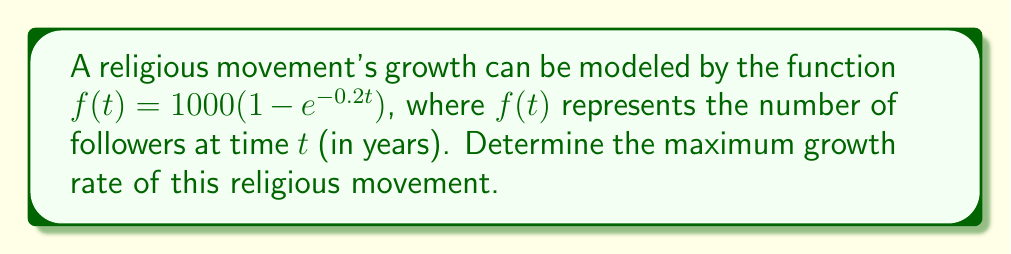Provide a solution to this math problem. To find the maximum growth rate, we need to follow these steps:

1) First, we need to find the derivative of $f(t)$ with respect to $t$. This will give us the growth rate function.

   $f'(t) = 1000 \cdot 0.2e^{-0.2t} = 200e^{-0.2t}$

2) The growth rate function $f'(t)$ represents the rate of change of followers over time. To find the maximum growth rate, we need to find the maximum value of this function.

3) In this case, $f'(t)$ is a decreasing exponential function. Its maximum value occurs at $t = 0$.

4) Therefore, we can find the maximum growth rate by evaluating $f'(0)$:

   $f'(0) = 200e^{-0.2 \cdot 0} = 200e^0 = 200$

5) This means that the maximum growth rate is 200 followers per year, which occurs at the beginning of the movement's growth $(t = 0)$.
Answer: 200 followers per year 